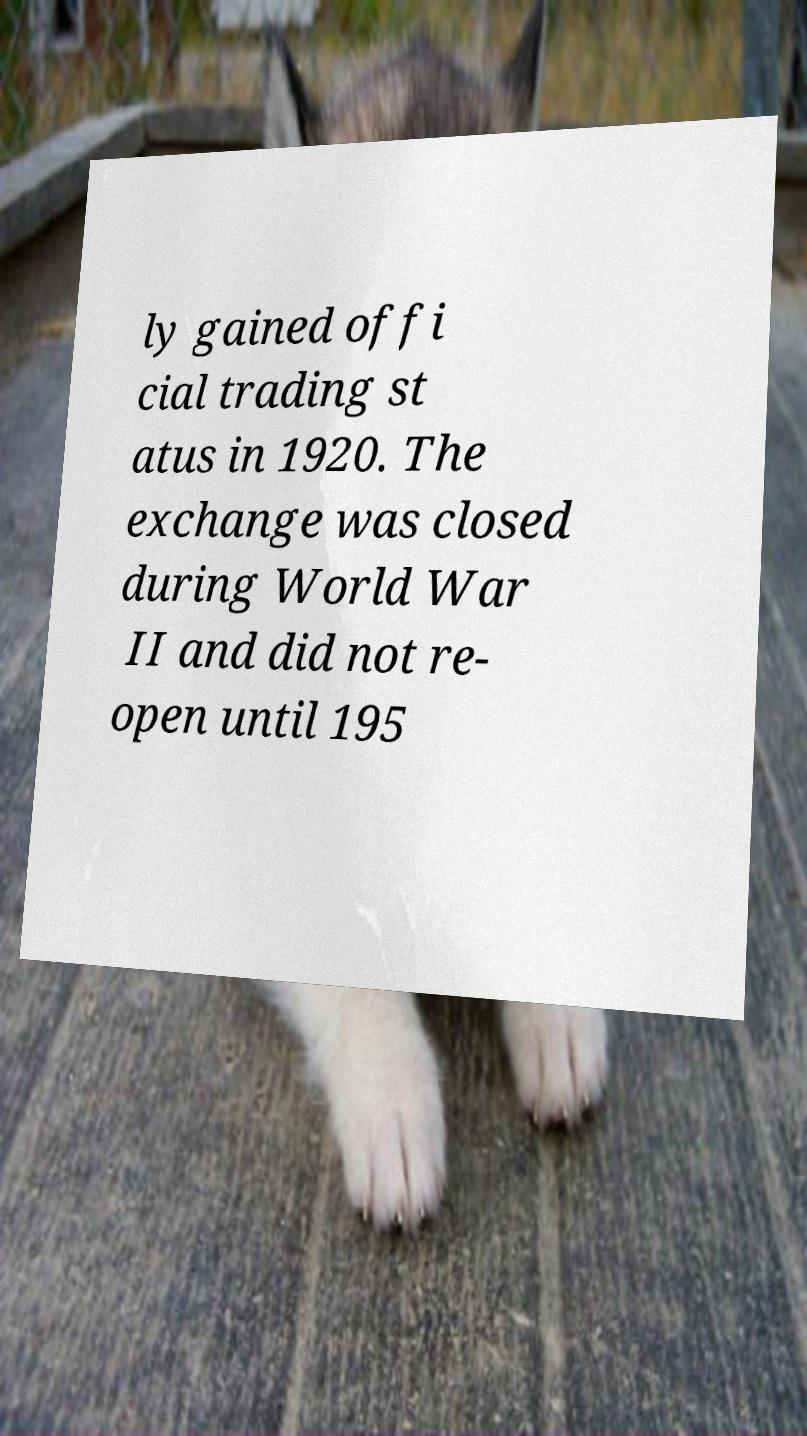For documentation purposes, I need the text within this image transcribed. Could you provide that? ly gained offi cial trading st atus in 1920. The exchange was closed during World War II and did not re- open until 195 